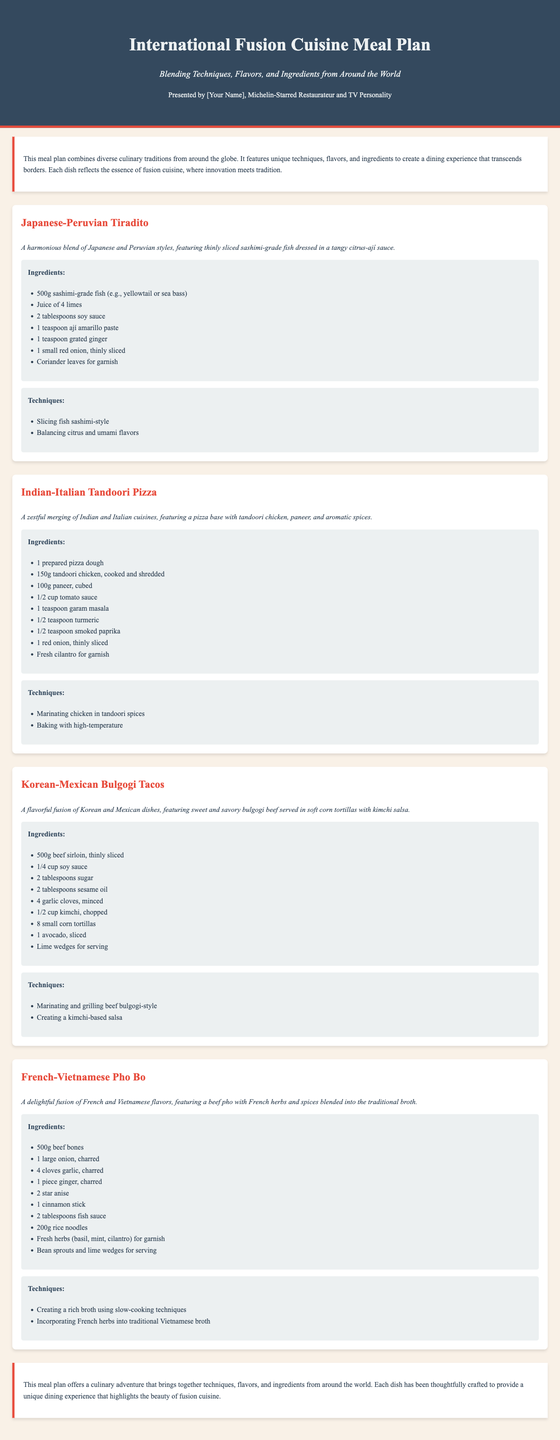What is the title of the meal plan? The title of the meal plan is prominently displayed at the top of the document.
Answer: International Fusion Cuisine Meal Plan Who is the presenter of the meal plan? The presenter is mentioned in the header of the document, indicating their professional background.
Answer: [Your Name] How many dishes are included in the meal plan? The document lists four distinct dishes under the meal plan section.
Answer: Four What is the primary cuisine style of the first dish? The first dish combines elements from two distinct culinary traditions.
Answer: Japanese-Peruvian What is a key ingredient in the Indian-Italian Tandoori Pizza? Ingredients are detailed for each dish, and one is particularly notable.
Answer: Tandoori chicken What cooking technique is used for the Korean-Mexican Bulgogi Tacos? The document outlines specific techniques applied to the preparation of the dishes.
Answer: Marinating and grilling beef bulgogi-style Which herb is used for garnish in the French-Vietnamese Pho Bo? The ingredients section for the French-Vietnamese Pho Bo specifies fresh herbs for garnish.
Answer: Fresh herbs (basil, mint, cilantro) What is the flavor profile of the Japanese-Peruvian Tiradito? The meal description outlines flavor characteristics for each dish.
Answer: Tangy citrus-ají sauce What cooking method is emphasized in creating the broth for the French-Vietnamese Pho Bo? The techniques section highlights important methods used in dish preparation.
Answer: Slow-cooking techniques 